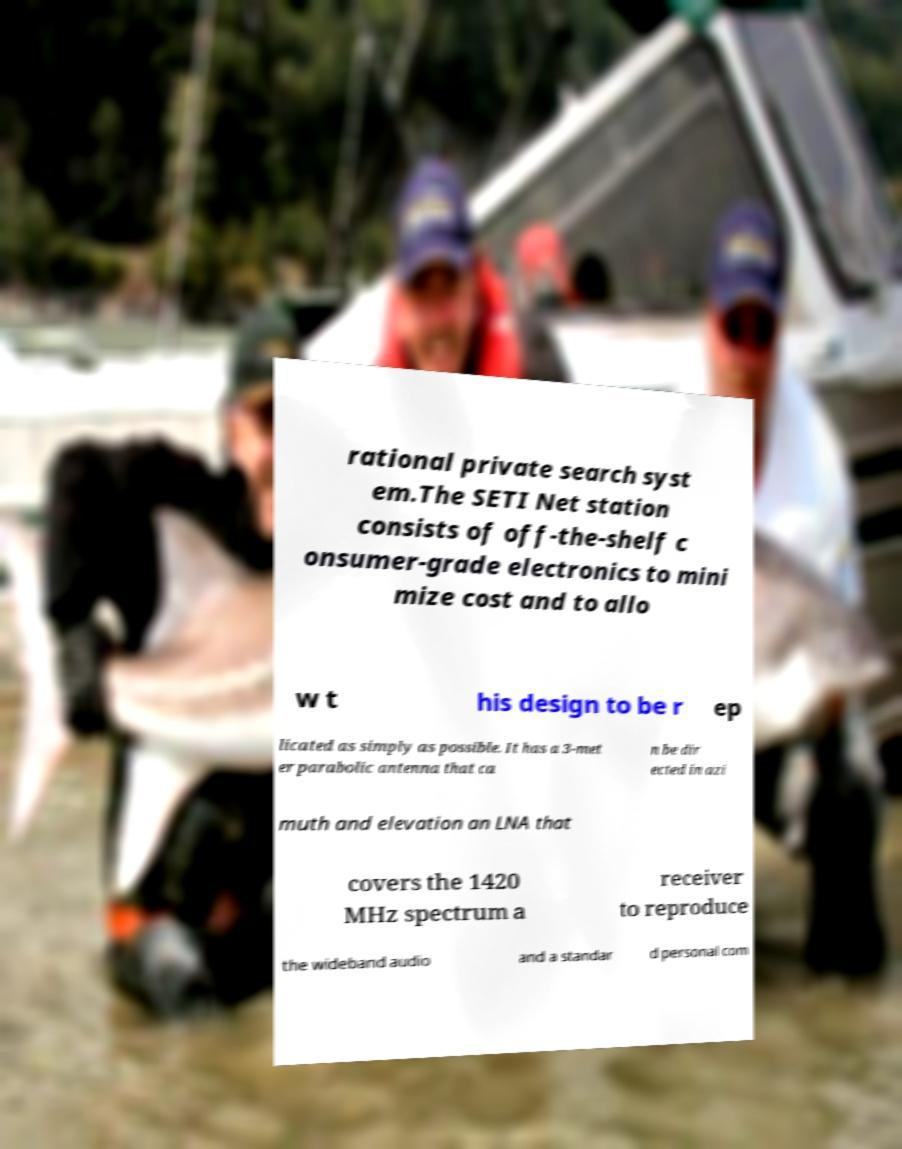Could you assist in decoding the text presented in this image and type it out clearly? rational private search syst em.The SETI Net station consists of off-the-shelf c onsumer-grade electronics to mini mize cost and to allo w t his design to be r ep licated as simply as possible. It has a 3-met er parabolic antenna that ca n be dir ected in azi muth and elevation an LNA that covers the 1420 MHz spectrum a receiver to reproduce the wideband audio and a standar d personal com 